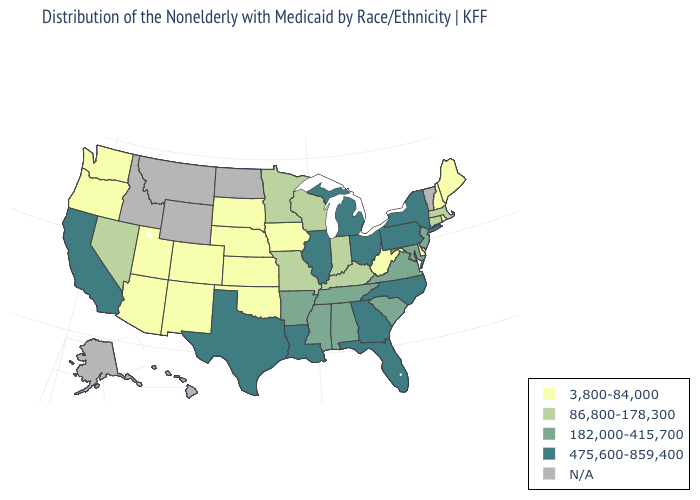What is the value of New Jersey?
Answer briefly. 182,000-415,700. Name the states that have a value in the range 475,600-859,400?
Keep it brief. California, Florida, Georgia, Illinois, Louisiana, Michigan, New York, North Carolina, Ohio, Pennsylvania, Texas. Name the states that have a value in the range 182,000-415,700?
Write a very short answer. Alabama, Arkansas, Maryland, Mississippi, New Jersey, South Carolina, Tennessee, Virginia. What is the highest value in states that border West Virginia?
Short answer required. 475,600-859,400. Does Colorado have the highest value in the USA?
Concise answer only. No. How many symbols are there in the legend?
Short answer required. 5. What is the lowest value in states that border Florida?
Answer briefly. 182,000-415,700. Name the states that have a value in the range 475,600-859,400?
Short answer required. California, Florida, Georgia, Illinois, Louisiana, Michigan, New York, North Carolina, Ohio, Pennsylvania, Texas. What is the highest value in states that border California?
Short answer required. 86,800-178,300. Does the first symbol in the legend represent the smallest category?
Short answer required. Yes. Does Iowa have the highest value in the MidWest?
Write a very short answer. No. Among the states that border Kansas , which have the lowest value?
Be succinct. Colorado, Nebraska, Oklahoma. What is the value of Virginia?
Answer briefly. 182,000-415,700. Which states have the lowest value in the USA?
Give a very brief answer. Arizona, Colorado, Delaware, Iowa, Kansas, Maine, Nebraska, New Hampshire, New Mexico, Oklahoma, Oregon, Rhode Island, South Dakota, Utah, Washington, West Virginia. 